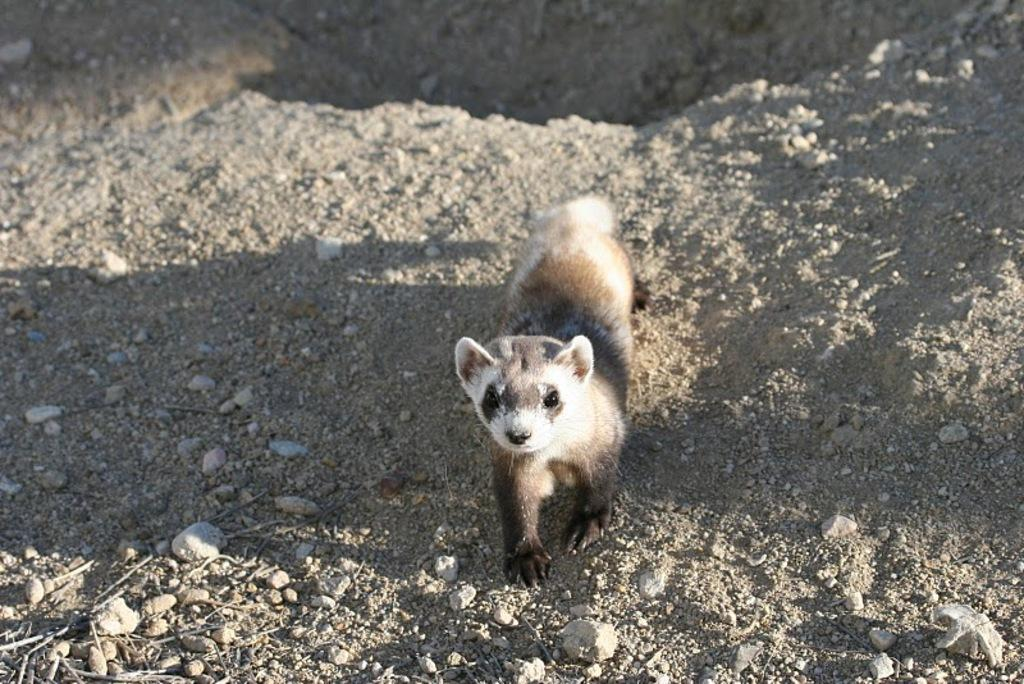What type of animal is in the image? There is a weasel in the image. Where is the weasel located in the image? The weasel is present on the ground. What type of development can be seen in the image? There is no development present in the image; it only features a weasel on the ground. 